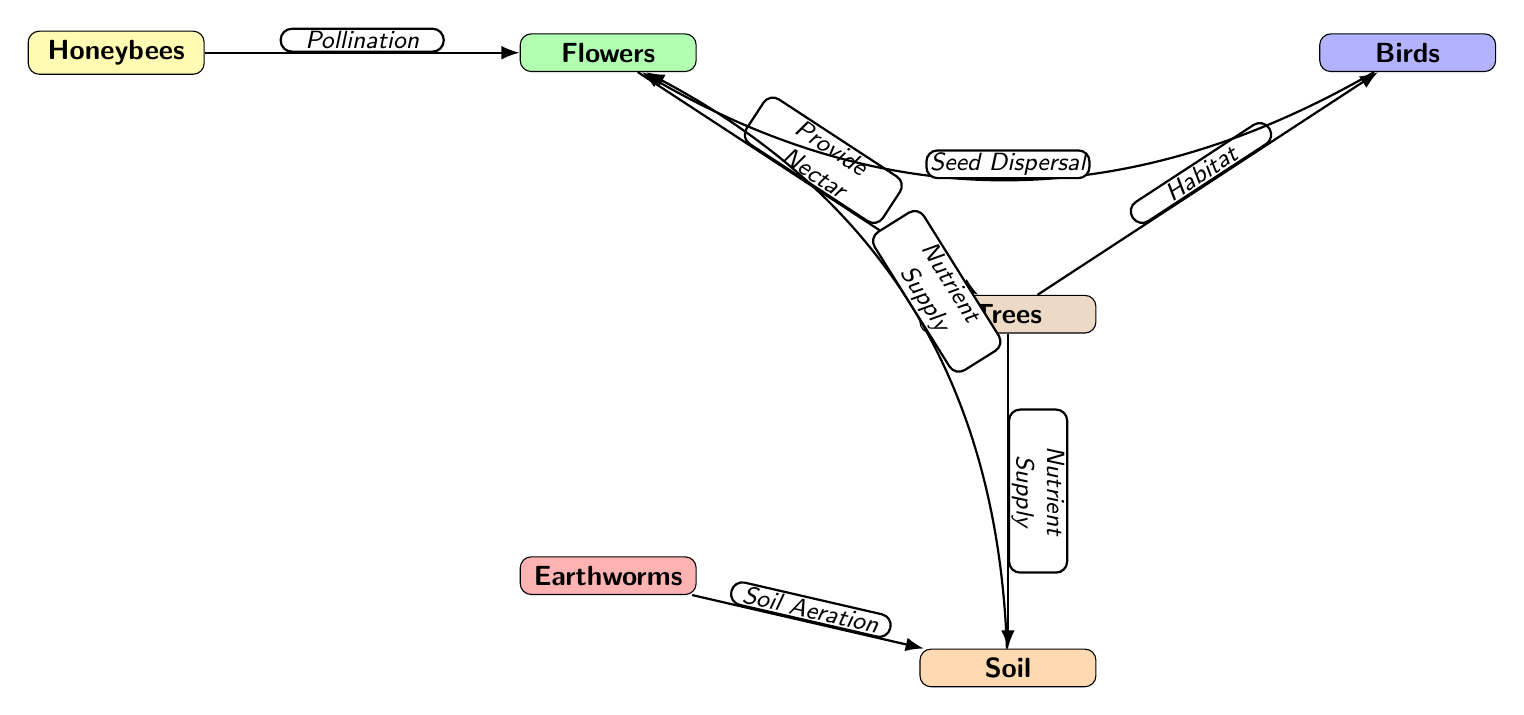What's the total number of nodes in the diagram? The diagram contains six nodes representing different species: Honeybees, Flowers, Trees, Birds, Earthworms, and Soil. Counting them gives us a total of six nodes.
Answer: 6 What does the edge from Honeybees to Flowers represent? The edge connecting Honeybees to Flowers is labeled "Pollination," indicating that Honeybees contribute to the pollination process of Flowers.
Answer: Pollination Which species provides nectar to Trees? The edge from Flowers to Trees indicates that Flowers provide nectar to Trees, as shown by the label on the edge.
Answer: Flowers What role do Earthworms play in the ecosystem according to the diagram? The edge leading from Earthworms to Soil is labeled "Soil Aeration," which suggests that Earthworms contribute to the aeration of the soil, making it more suitable for plant growth.
Answer: Soil Aeration How do Trees contribute to the lives of Birds? The edge from Trees to Birds is labeled "Habitat," showing that Trees provide habitat or living space for Birds, which is crucial for their sustenance and reproduction.
Answer: Habitat What is the result of Trees providing nutrient supply? The edge from Trees to Soil indicates that Trees provide nutrients to Soil, which improves soil fertility and supports the growth of plants, including Flowers.
Answer: Nutrient Supply What is the relationship between Soil and Flowers? The edge from Soil to Flowers is labeled "Nutrient Supply," illustrating that Soil supplies nutrients to Flowers, aiding in their growth and health.
Answer: Nutrient Supply Which species is involved in seed dispersal? The edge from Birds to Flowers is labeled "Seed Dispersal," indicating that Birds play a role in the dispersal of seeds from Flowers to new areas for growth.
Answer: Birds In the diagram, which species supports the majority of interactions? The node representing Trees shows multiple interactions as it receives nectar from Flowers, provides habitat for Birds, and supplies nutrients to Soil, indicating that Trees support many interactions within the ecosystem.
Answer: Trees 